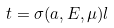Convert formula to latex. <formula><loc_0><loc_0><loc_500><loc_500>t = \sigma ( a , E , \mu ) l</formula> 